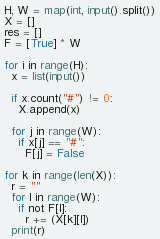Convert code to text. <code><loc_0><loc_0><loc_500><loc_500><_Python_>H, W = map(int, input().split())
X = []
res = []
F = [True] * W

for i in range(H):
  x = list(input())
   
  if x.count("#") != 0:
    X.append(x)

  for j in range(W):
    if x[j] == "#":
      F[j] = False

for k in range(len(X)):
  r = ""
  for l in range(W):
    if not F[l]:
      r += (X[k][l])
  print(r)</code> 